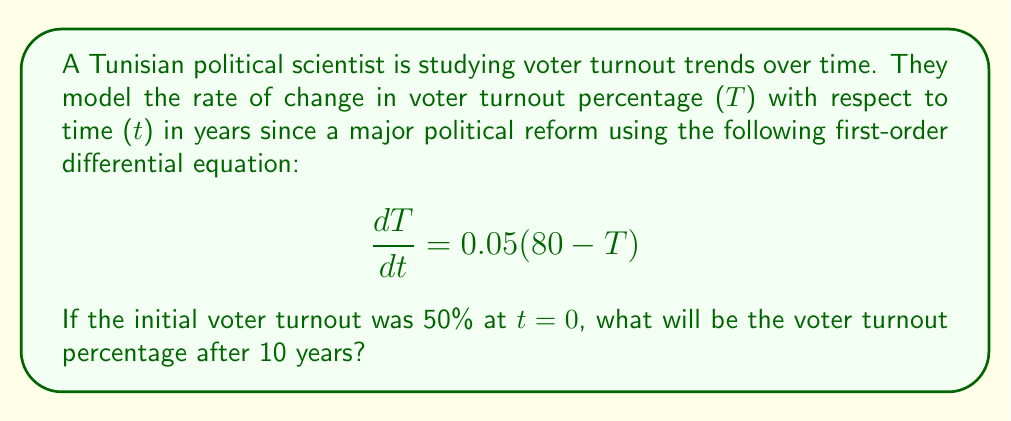Give your solution to this math problem. To solve this problem, we need to follow these steps:

1) First, we recognize this as a first-order linear differential equation in the form:
   $$\frac{dT}{dt} = k(A - T)$$
   where k = 0.05, A = 80, and the initial condition is T(0) = 50.

2) The solution to this type of equation is:
   $$T(t) = A + (T_0 - A)e^{-kt}$$
   where T_0 is the initial value of T.

3) Substituting our values:
   $$T(t) = 80 + (50 - 80)e^{-0.05t}$$

4) Simplify:
   $$T(t) = 80 - 30e^{-0.05t}$$

5) To find the voter turnout after 10 years, we substitute t = 10:
   $$T(10) = 80 - 30e^{-0.05(10)}$$

6) Calculate:
   $$T(10) = 80 - 30e^{-0.5}$$
   $$T(10) = 80 - 30(0.6065)$$
   $$T(10) = 80 - 18.195$$
   $$T(10) = 61.805$$

Therefore, after 10 years, the voter turnout percentage will be approximately 61.805%.
Answer: 61.805% 